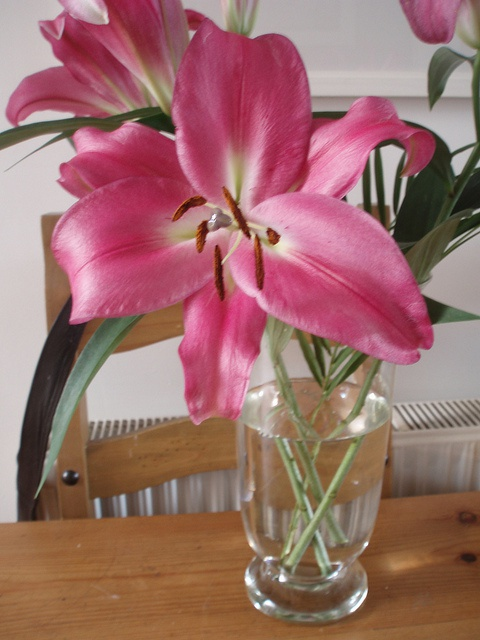Describe the objects in this image and their specific colors. I can see dining table in darkgray, brown, maroon, and gray tones, vase in darkgray and gray tones, and chair in darkgray, brown, maroon, and gray tones in this image. 